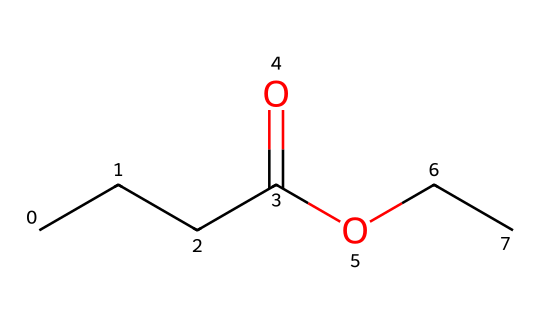What is the chemical name of the substance represented by this SMILES? The SMILES structure "CCCC(=O)OCC" indicates an ester formed from butanoic acid (derived from the "CCCC(=O)" part) and ethanol (from "OCC"). Thus, combining these names results in the chemical name ethyl butyrate.
Answer: ethyl butyrate How many carbon atoms are in ethyl butyrate? The SMILES "CCCC(=O)OCC" contains 4 carbon atoms from butanoic acid (the 'CCCC') and 2 carbon atoms from the ethyl group ('CC'), totaling 6 carbon atoms.
Answer: 6 What type of functional group is present in this molecule? The presence of the "O" connected to carbon chains indicates a functional group characteristic of esters, specifically the carboxylate group (which forms when an acid reacts with an alcohol). This confirms the ester's identity.
Answer: ester What is the total number of hydrogen atoms in ethyl butyrate? Each carbon typically forms four bonds. In the given structure, the four carbons in butanoic acid account for 8 hydrogen atoms and the two in the ethyl group provide another 5 hydrogen atoms. Considering the loss of one hydrogen due to ester formation, the total becomes 12.
Answer: 12 Which part of the molecule represents the alcohol in the ester formation? In the SMILES, "OCC" represents the ethyl alcohol part of the ester as indicated by the 'O' connecting to the carbon. This suggests its origin from ethanol.
Answer: ethyl alcohol What type of smell is associated with ethyl butyrate? Ethyl butyrate is often described as having a fruity aroma, reminiscent of apples or pineapples, which is typical for many esters.
Answer: fruity What is the molecular formula of ethyl butyrate? By totaling the number of carbon (6), hydrogen (12), and oxygen (2) atoms indicated in the SMILES formula, the molecular formula becomes C6H12O2.
Answer: C6H12O2 